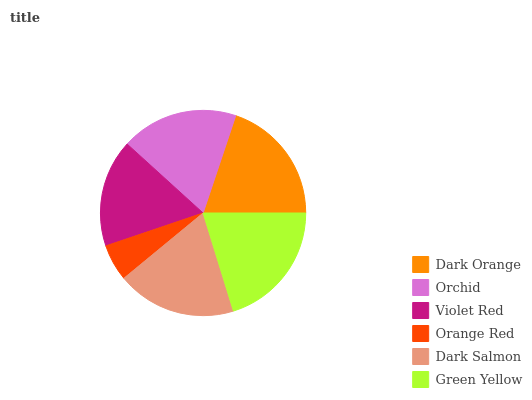Is Orange Red the minimum?
Answer yes or no. Yes. Is Green Yellow the maximum?
Answer yes or no. Yes. Is Orchid the minimum?
Answer yes or no. No. Is Orchid the maximum?
Answer yes or no. No. Is Dark Orange greater than Orchid?
Answer yes or no. Yes. Is Orchid less than Dark Orange?
Answer yes or no. Yes. Is Orchid greater than Dark Orange?
Answer yes or no. No. Is Dark Orange less than Orchid?
Answer yes or no. No. Is Dark Salmon the high median?
Answer yes or no. Yes. Is Orchid the low median?
Answer yes or no. Yes. Is Orchid the high median?
Answer yes or no. No. Is Orange Red the low median?
Answer yes or no. No. 